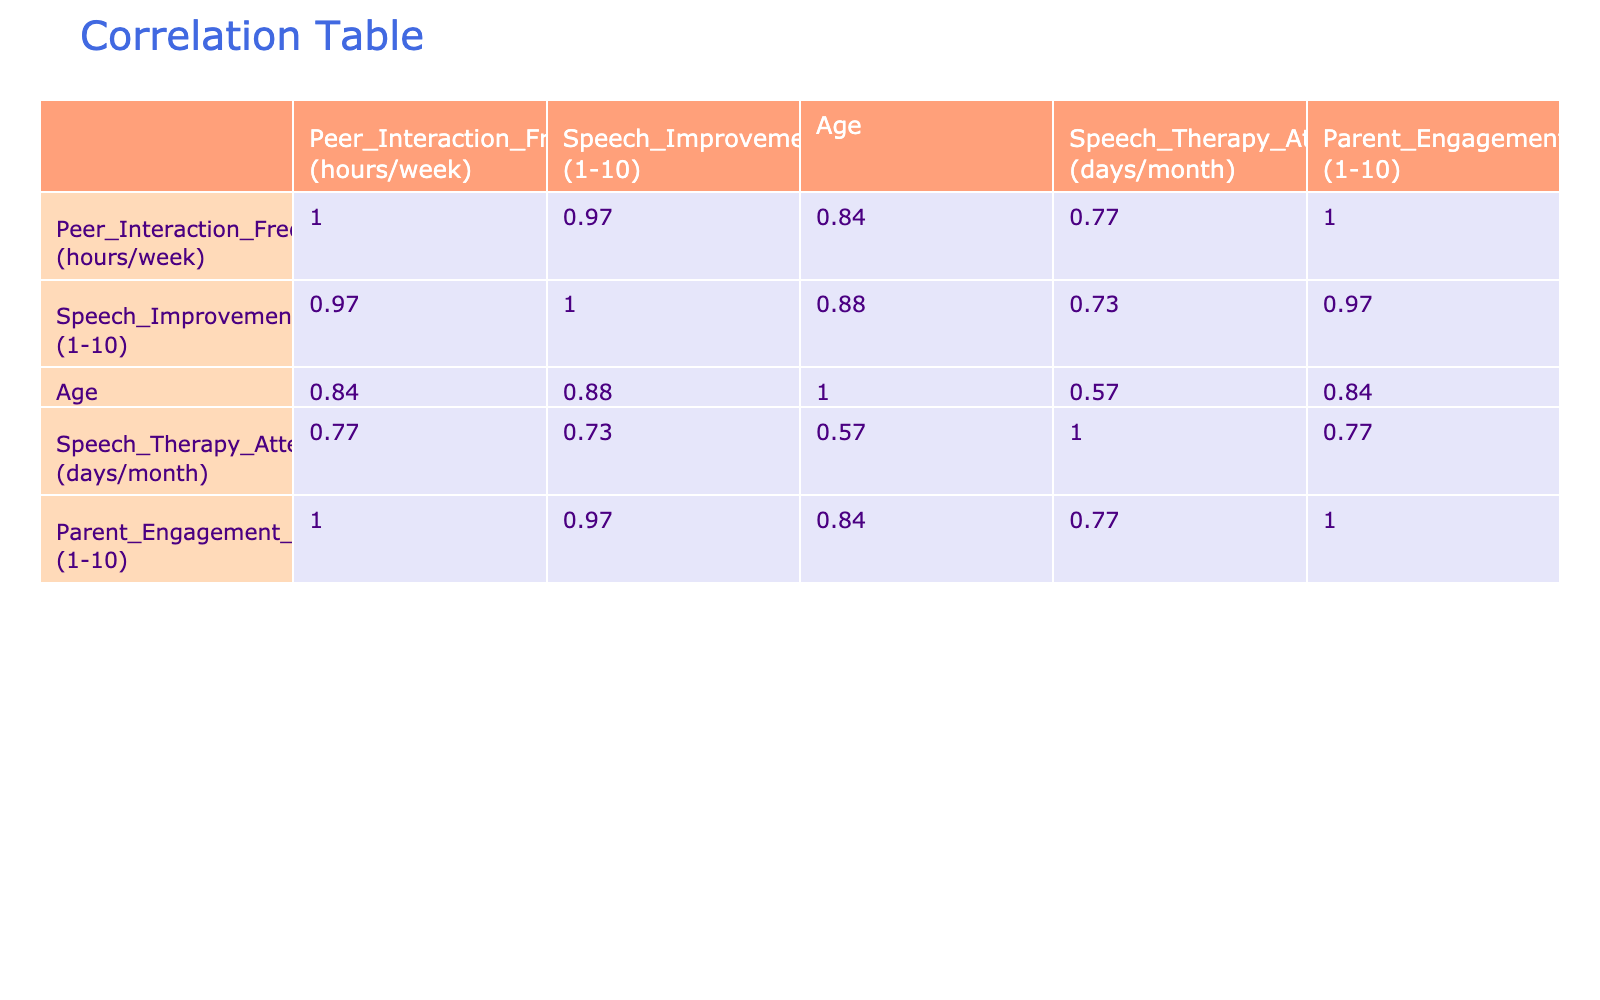What is the correlation coefficient between Peer Interaction Frequency and Speech Improvement Score? The table shows a correlation coefficient of 0.84, indicating a strong positive relationship between peer interaction frequency and speech improvement score. This suggests that as peer interaction frequency increases, speech improvement scores tend to rise as well.
Answer: 0.84 What is the lowest Speech Improvement Score recorded in the table? By checking the Speech Improvement Score column, the lowest value recorded is 2, which occurs in the row where Peer Interaction Frequency is 1 hour per week.
Answer: 2 Which age group has the highest average Speech Improvement Score? The ages are 6, 7, 8, and 9. For age 6, the score is 2. For age 7, the scores are 3 and 4 (average is 3.5). For age 8, the scores are 6, 5, and 9 (average is 6.67). For age 9, the score is 10. The highest average score is 10 for age 9.
Answer: Age 9 Is there a notable relationship between Speech Therapy Attendance and Speech Improvement Score? The correlation coefficient between Speech Therapy Attendance and Speech Improvement Score is 0.61, indicating a moderate positive relationship. Therefore, yes, higher attendance appears to be associated with better improvement scores.
Answer: Yes What is the average Speech Improvement Score for boys who have more than 7 hours of Peer Interaction per week? The scores with more than 7 hours of interaction are 9 (7 hours) and 10 (8 hours). Adding these gives us 9 + 10 = 19. There are 2 scores, so the average is 19/2 = 9.5.
Answer: 9.5 